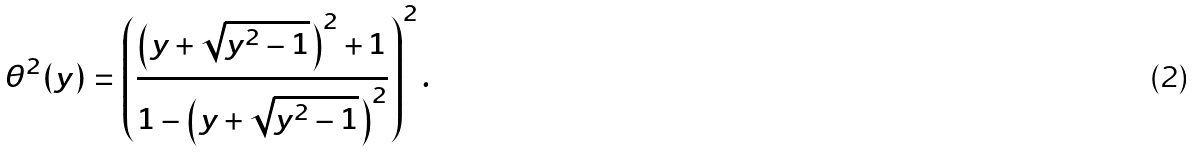<formula> <loc_0><loc_0><loc_500><loc_500>\theta ^ { 2 } ( y ) = \left ( \frac { \left ( y + \sqrt { y ^ { 2 } - 1 } \right ) ^ { 2 } + 1 } { 1 - \left ( y + \sqrt { y ^ { 2 } - 1 } \right ) ^ { 2 } } \right ) ^ { 2 } .</formula> 